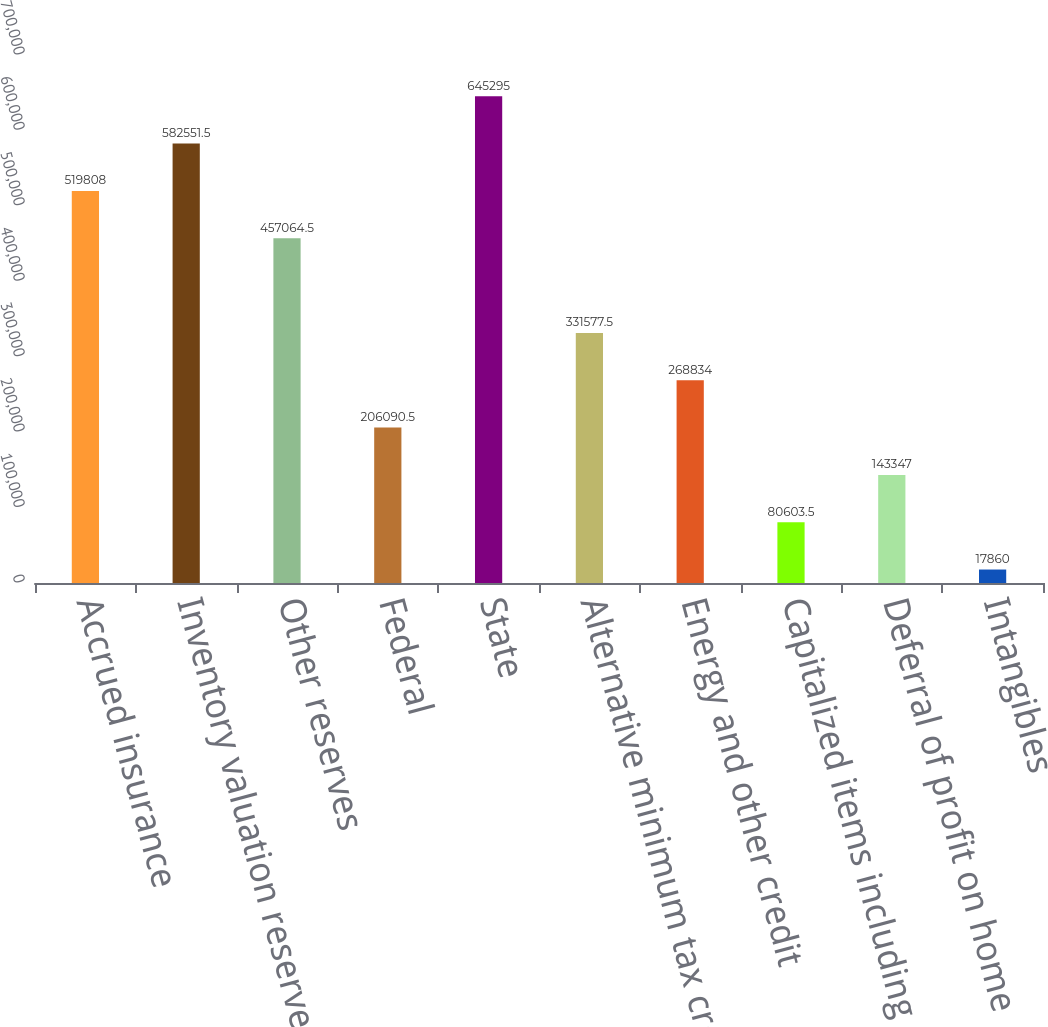<chart> <loc_0><loc_0><loc_500><loc_500><bar_chart><fcel>Accrued insurance<fcel>Inventory valuation reserves<fcel>Other reserves<fcel>Federal<fcel>State<fcel>Alternative minimum tax credit<fcel>Energy and other credit<fcel>Capitalized items including<fcel>Deferral of profit on home<fcel>Intangibles<nl><fcel>519808<fcel>582552<fcel>457064<fcel>206090<fcel>645295<fcel>331578<fcel>268834<fcel>80603.5<fcel>143347<fcel>17860<nl></chart> 